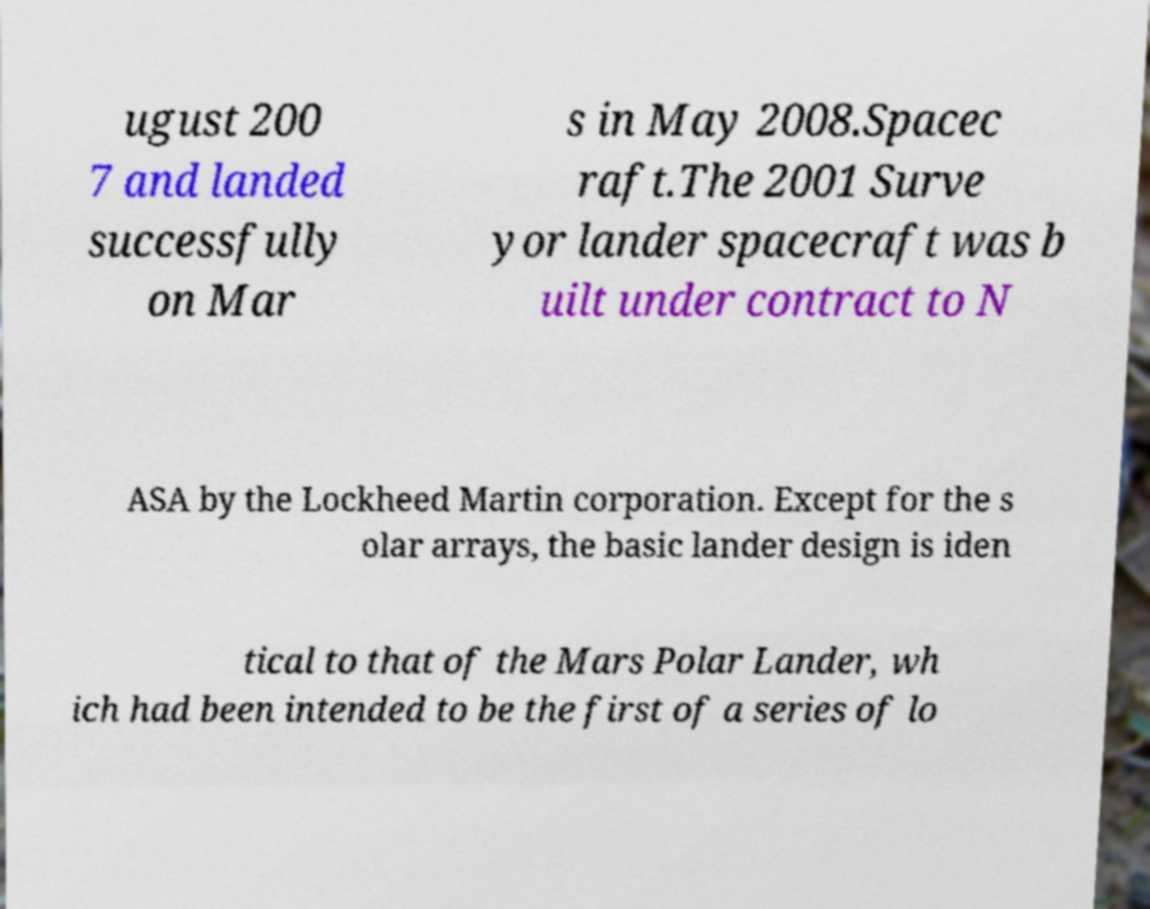Could you extract and type out the text from this image? ugust 200 7 and landed successfully on Mar s in May 2008.Spacec raft.The 2001 Surve yor lander spacecraft was b uilt under contract to N ASA by the Lockheed Martin corporation. Except for the s olar arrays, the basic lander design is iden tical to that of the Mars Polar Lander, wh ich had been intended to be the first of a series of lo 